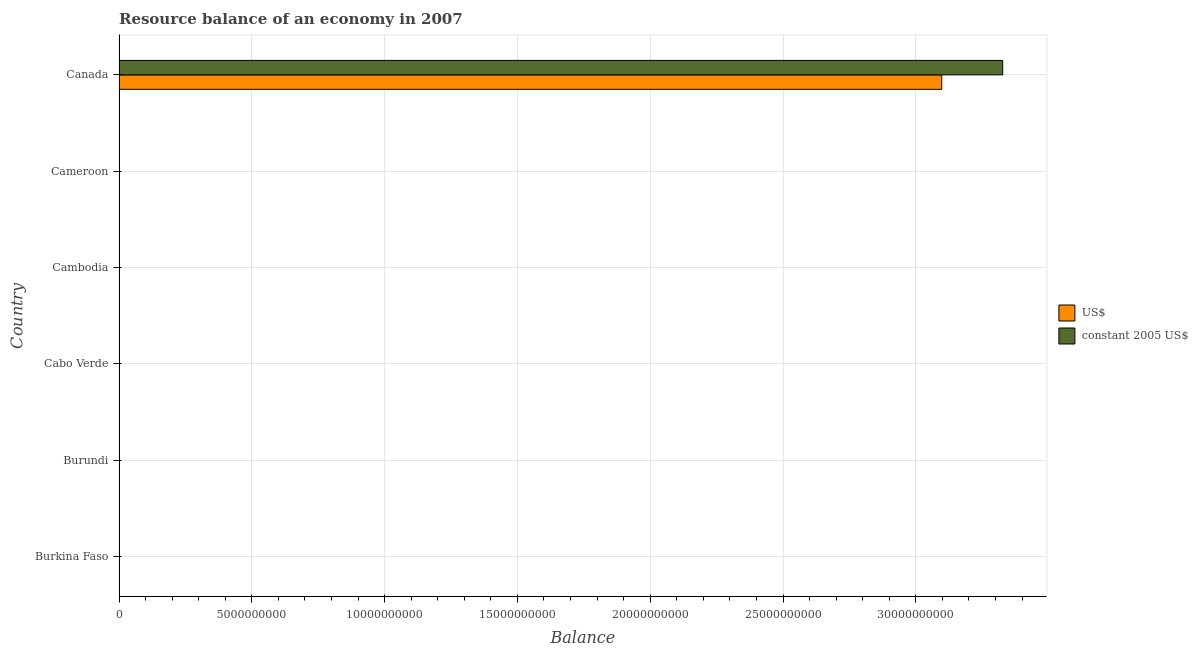How many different coloured bars are there?
Ensure brevity in your answer.  2. Are the number of bars per tick equal to the number of legend labels?
Give a very brief answer. No. Are the number of bars on each tick of the Y-axis equal?
Your answer should be compact. No. How many bars are there on the 5th tick from the top?
Keep it short and to the point. 0. What is the resource balance in us$ in Cabo Verde?
Your answer should be very brief. 0. Across all countries, what is the maximum resource balance in us$?
Keep it short and to the point. 3.10e+1. Across all countries, what is the minimum resource balance in us$?
Your answer should be compact. 0. What is the total resource balance in us$ in the graph?
Make the answer very short. 3.10e+1. What is the average resource balance in constant us$ per country?
Offer a very short reply. 5.55e+09. What is the difference between the resource balance in constant us$ and resource balance in us$ in Canada?
Ensure brevity in your answer.  2.30e+09. What is the difference between the highest and the lowest resource balance in constant us$?
Your response must be concise. 3.33e+1. In how many countries, is the resource balance in us$ greater than the average resource balance in us$ taken over all countries?
Your response must be concise. 1. How many bars are there?
Offer a terse response. 2. How many countries are there in the graph?
Make the answer very short. 6. Does the graph contain any zero values?
Make the answer very short. Yes. Where does the legend appear in the graph?
Keep it short and to the point. Center right. How many legend labels are there?
Provide a short and direct response. 2. How are the legend labels stacked?
Ensure brevity in your answer.  Vertical. What is the title of the graph?
Make the answer very short. Resource balance of an economy in 2007. What is the label or title of the X-axis?
Offer a very short reply. Balance. What is the Balance in constant 2005 US$ in Burkina Faso?
Your answer should be compact. 0. What is the Balance in constant 2005 US$ in Burundi?
Provide a succinct answer. 0. What is the Balance of US$ in Cabo Verde?
Keep it short and to the point. 0. What is the Balance of US$ in Cambodia?
Your answer should be very brief. 0. What is the Balance of constant 2005 US$ in Cambodia?
Keep it short and to the point. 0. What is the Balance in US$ in Cameroon?
Your answer should be very brief. 0. What is the Balance of US$ in Canada?
Keep it short and to the point. 3.10e+1. What is the Balance of constant 2005 US$ in Canada?
Keep it short and to the point. 3.33e+1. Across all countries, what is the maximum Balance in US$?
Provide a short and direct response. 3.10e+1. Across all countries, what is the maximum Balance in constant 2005 US$?
Provide a short and direct response. 3.33e+1. What is the total Balance in US$ in the graph?
Provide a short and direct response. 3.10e+1. What is the total Balance of constant 2005 US$ in the graph?
Offer a terse response. 3.33e+1. What is the average Balance in US$ per country?
Your answer should be compact. 5.16e+09. What is the average Balance of constant 2005 US$ per country?
Offer a terse response. 5.55e+09. What is the difference between the Balance of US$ and Balance of constant 2005 US$ in Canada?
Ensure brevity in your answer.  -2.30e+09. What is the difference between the highest and the lowest Balance of US$?
Your response must be concise. 3.10e+1. What is the difference between the highest and the lowest Balance in constant 2005 US$?
Provide a succinct answer. 3.33e+1. 